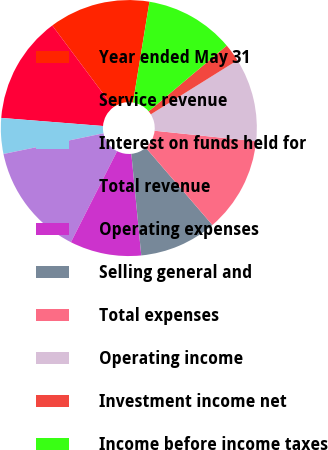Convert chart to OTSL. <chart><loc_0><loc_0><loc_500><loc_500><pie_chart><fcel>Year ended May 31<fcel>Service revenue<fcel>Interest on funds held for<fcel>Total revenue<fcel>Operating expenses<fcel>Selling general and<fcel>Total expenses<fcel>Operating income<fcel>Investment income net<fcel>Income before income taxes<nl><fcel>12.78%<fcel>13.53%<fcel>4.51%<fcel>14.28%<fcel>9.02%<fcel>9.77%<fcel>12.03%<fcel>10.53%<fcel>2.26%<fcel>11.28%<nl></chart> 